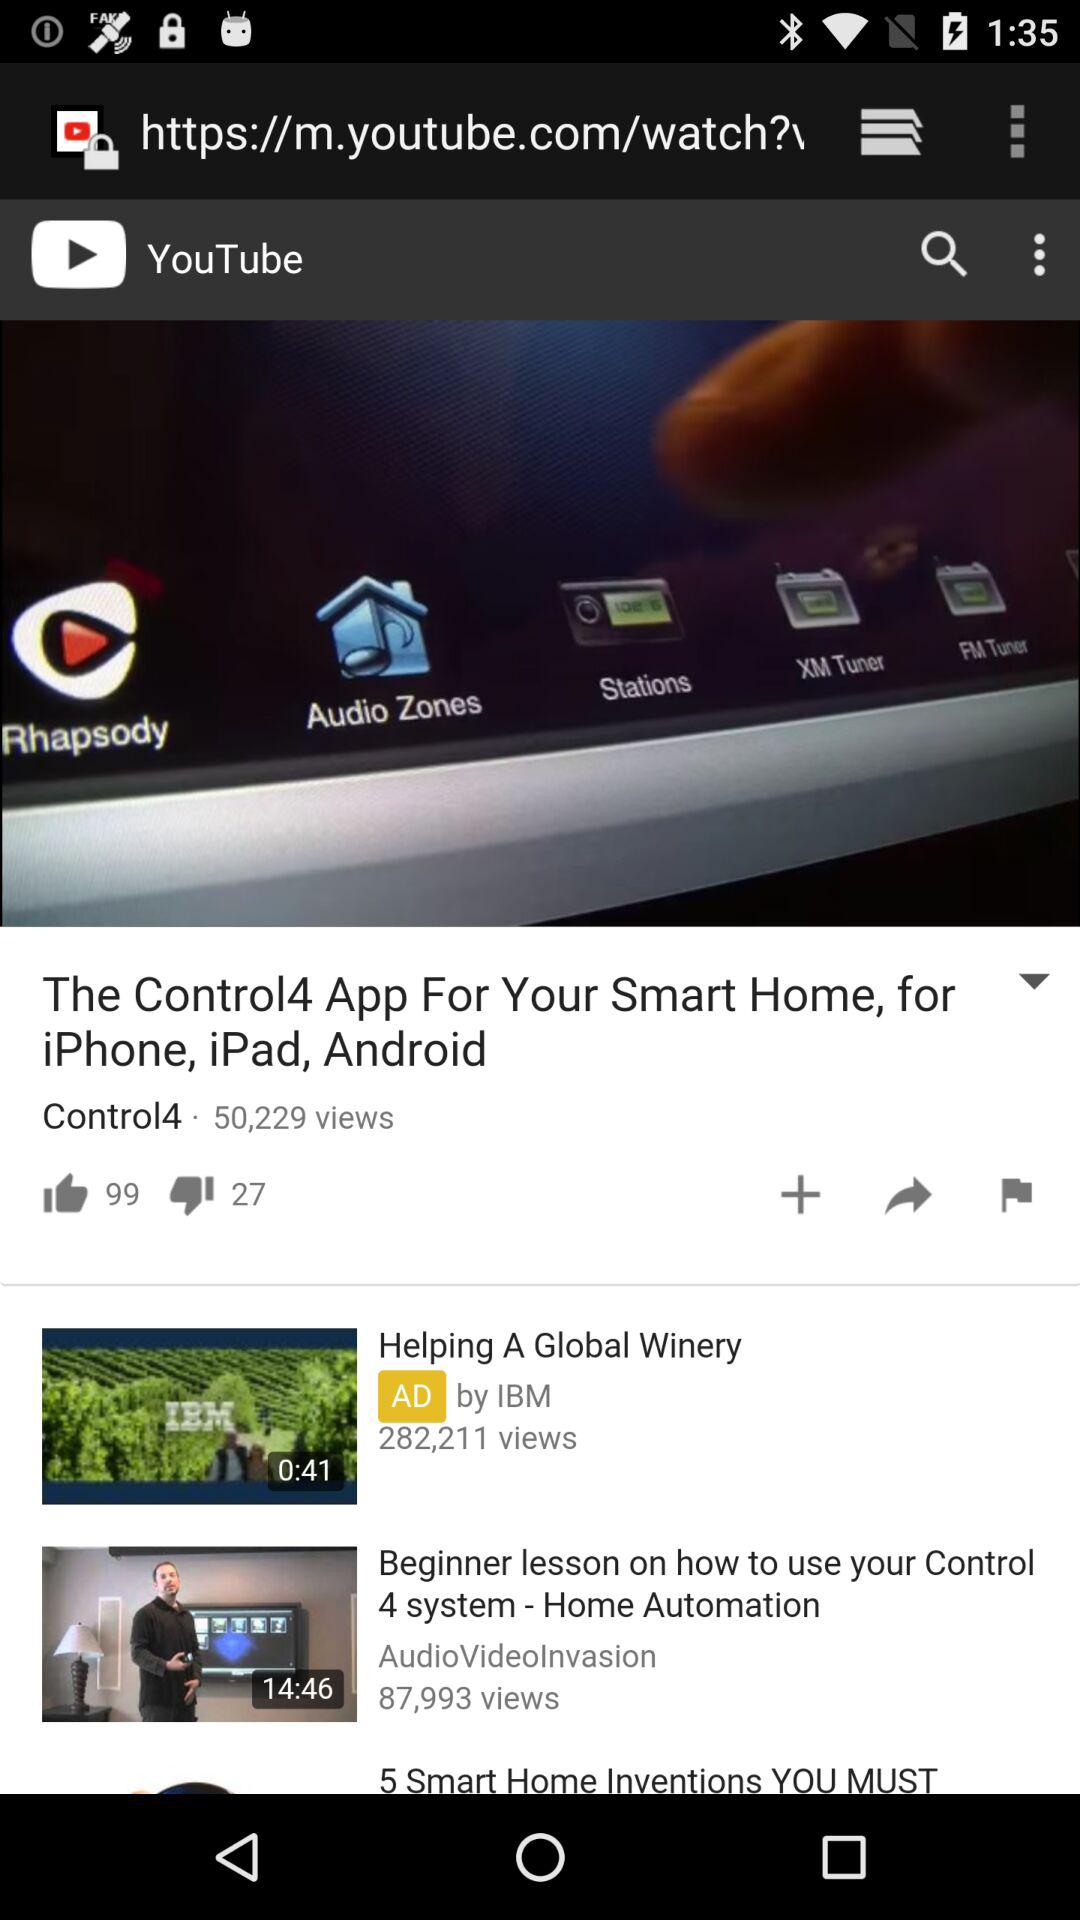How many more thumbs up than thumbs down are there on this video?
Answer the question using a single word or phrase. 72 